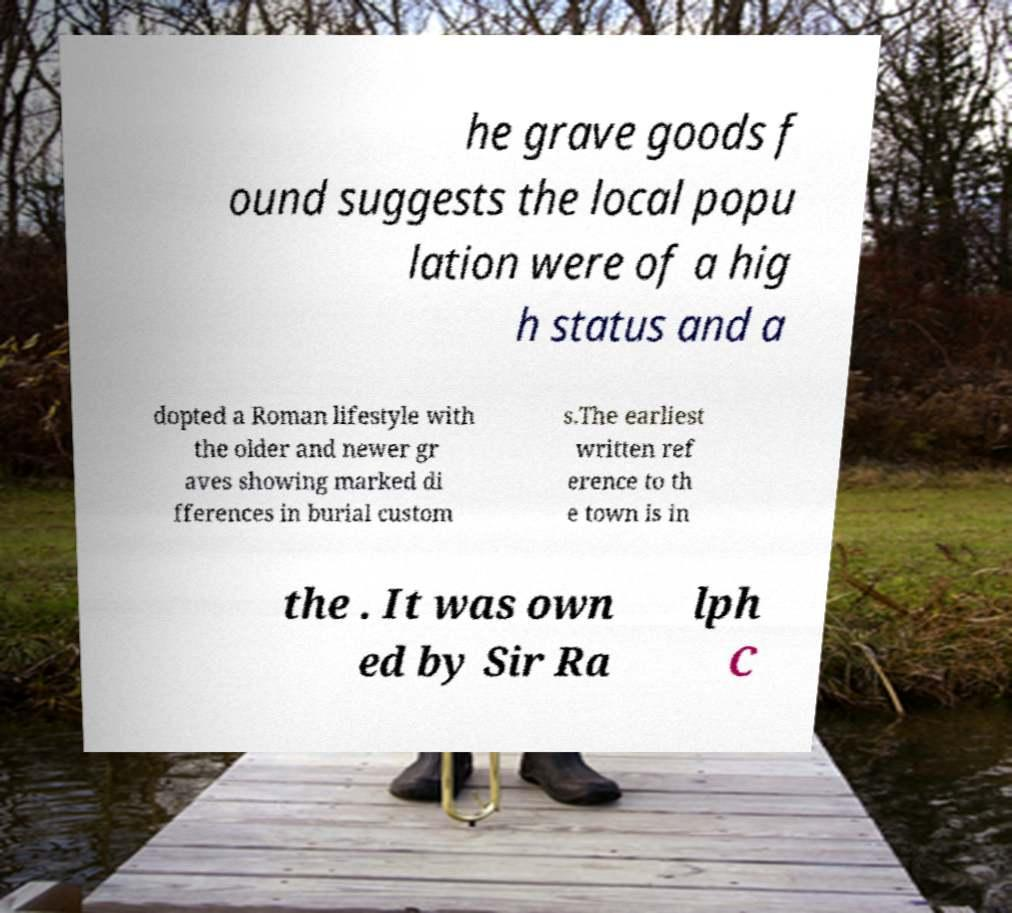Could you extract and type out the text from this image? he grave goods f ound suggests the local popu lation were of a hig h status and a dopted a Roman lifestyle with the older and newer gr aves showing marked di fferences in burial custom s.The earliest written ref erence to th e town is in the . It was own ed by Sir Ra lph C 